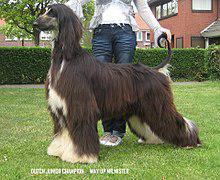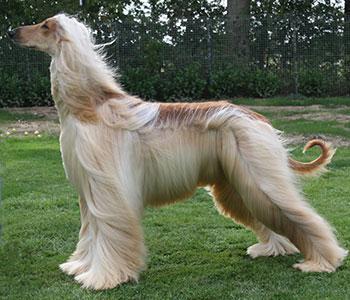The first image is the image on the left, the second image is the image on the right. Evaluate the accuracy of this statement regarding the images: "The bodies of the dogs in the paired images are turned in the same direction.". Is it true? Answer yes or no. Yes. 